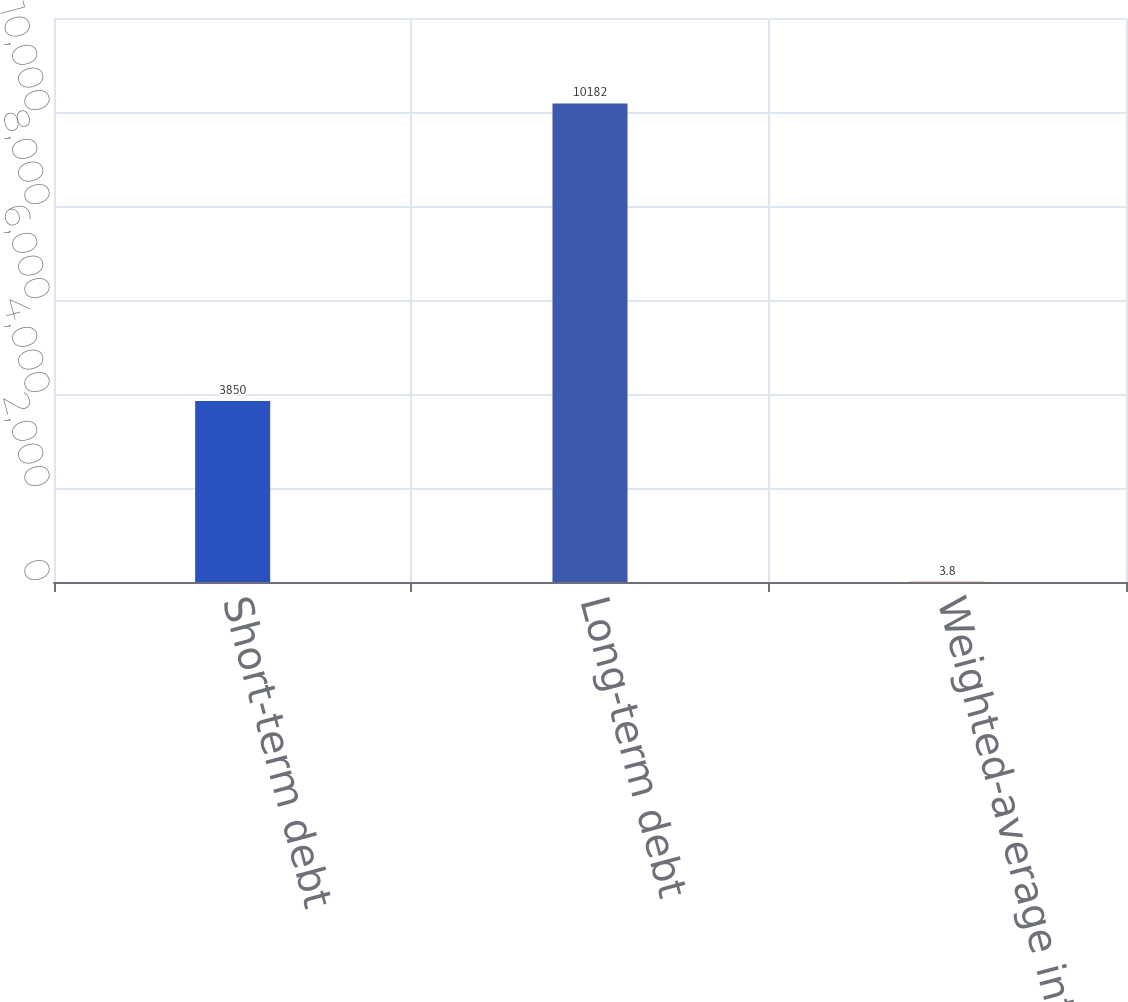Convert chart. <chart><loc_0><loc_0><loc_500><loc_500><bar_chart><fcel>Short-term debt<fcel>Long-term debt<fcel>Weighted-average interest rate<nl><fcel>3850<fcel>10182<fcel>3.8<nl></chart> 